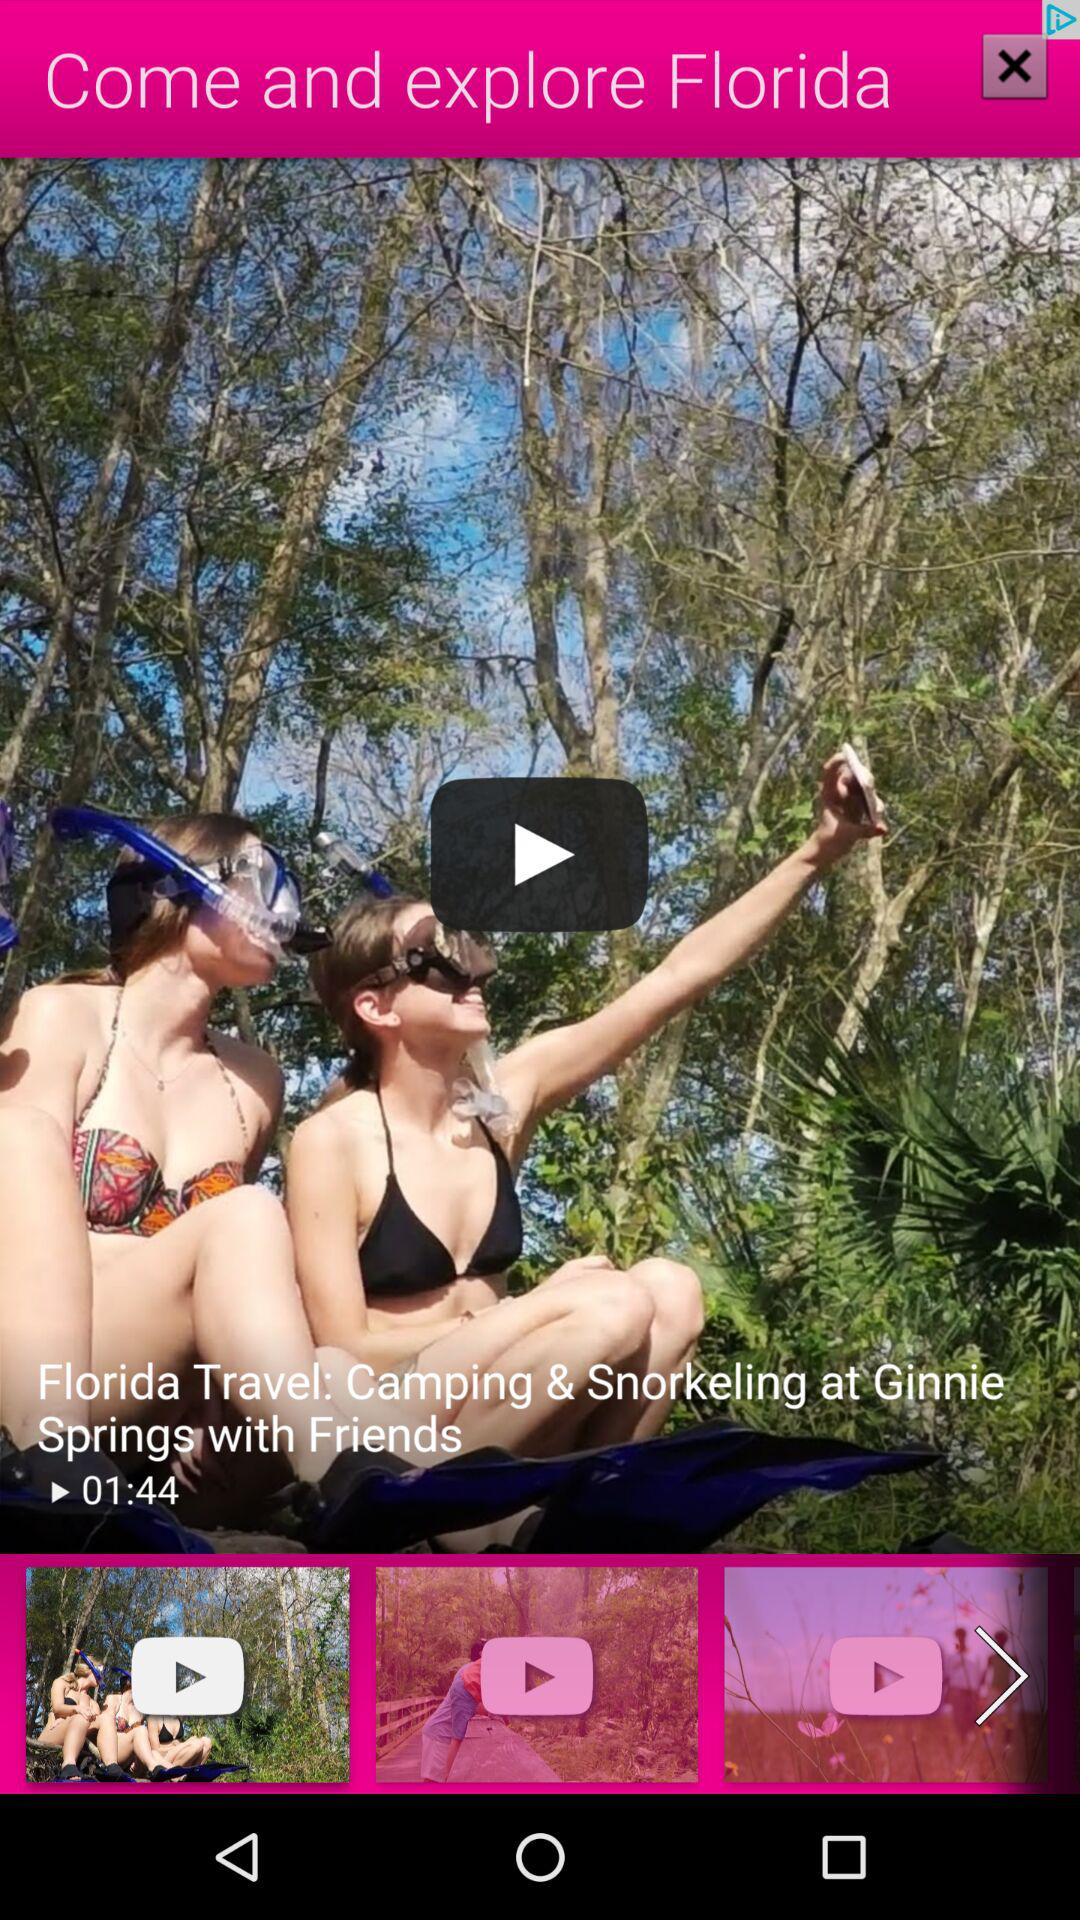How long is the video? The video is 1 minute 44 seconds long. 